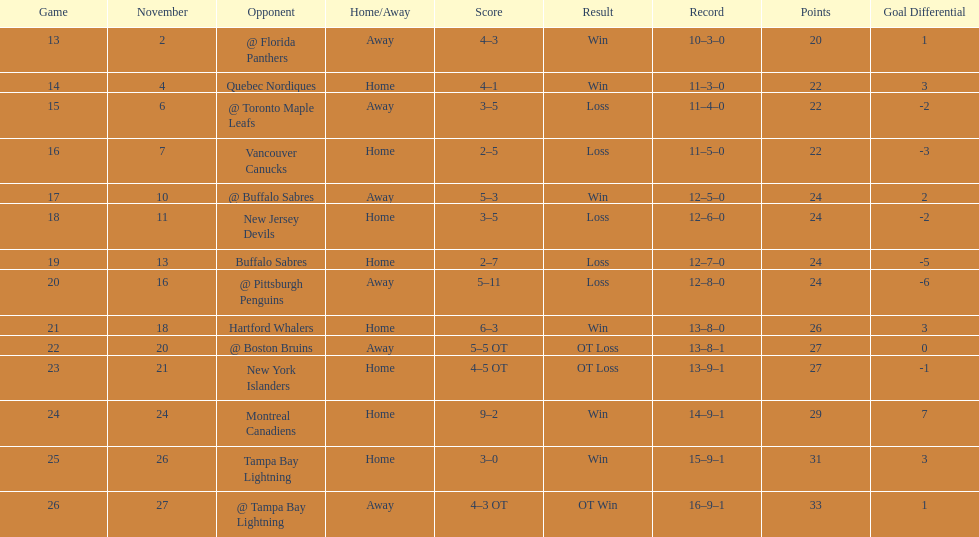Who had the most assists on the 1993-1994 flyers? Mark Recchi. 